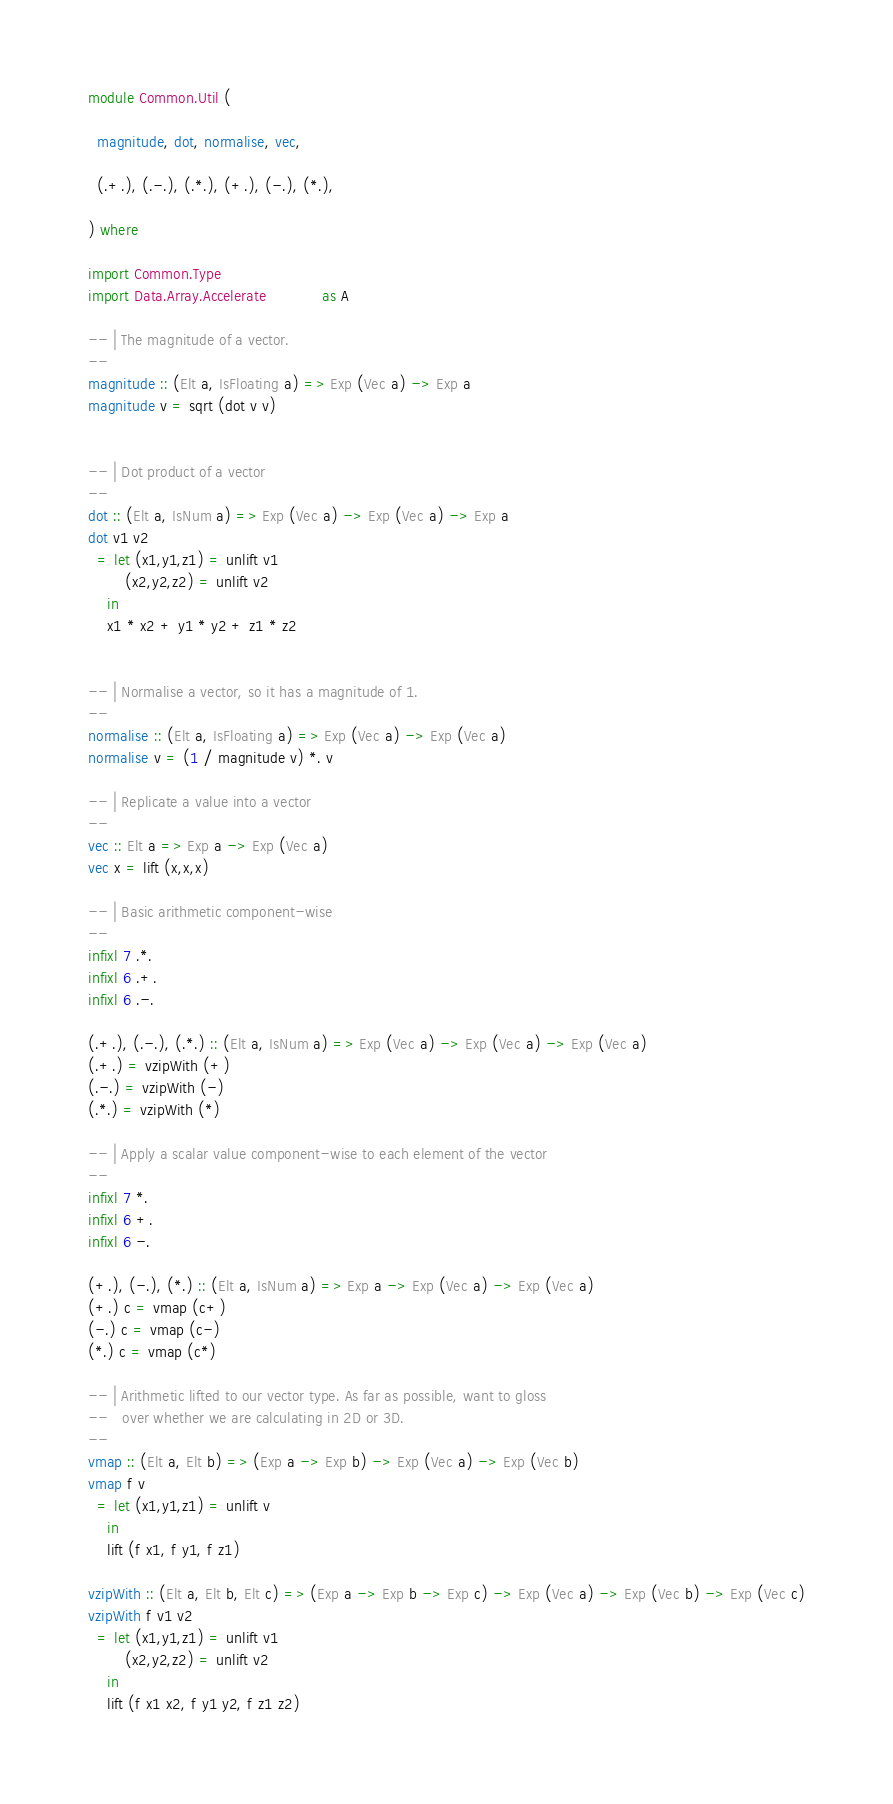<code> <loc_0><loc_0><loc_500><loc_500><_Haskell_>
module Common.Util (

  magnitude, dot, normalise, vec,

  (.+.), (.-.), (.*.), (+.), (-.), (*.),

) where

import Common.Type
import Data.Array.Accelerate            as A

-- | The magnitude of a vector.
--
magnitude :: (Elt a, IsFloating a) => Exp (Vec a) -> Exp a
magnitude v = sqrt (dot v v)


-- | Dot product of a vector
--
dot :: (Elt a, IsNum a) => Exp (Vec a) -> Exp (Vec a) -> Exp a
dot v1 v2
  = let (x1,y1,z1) = unlift v1
        (x2,y2,z2) = unlift v2
    in
    x1 * x2 + y1 * y2 + z1 * z2


-- | Normalise a vector, so it has a magnitude of 1.
--
normalise :: (Elt a, IsFloating a) => Exp (Vec a) -> Exp (Vec a)
normalise v = (1 / magnitude v) *. v

-- | Replicate a value into a vector
--
vec :: Elt a => Exp a -> Exp (Vec a)
vec x = lift (x,x,x)

-- | Basic arithmetic component-wise
--
infixl 7 .*.
infixl 6 .+.
infixl 6 .-.

(.+.), (.-.), (.*.) :: (Elt a, IsNum a) => Exp (Vec a) -> Exp (Vec a) -> Exp (Vec a)
(.+.) = vzipWith (+)
(.-.) = vzipWith (-)
(.*.) = vzipWith (*)

-- | Apply a scalar value component-wise to each element of the vector
--
infixl 7 *.
infixl 6 +.
infixl 6 -.

(+.), (-.), (*.) :: (Elt a, IsNum a) => Exp a -> Exp (Vec a) -> Exp (Vec a)
(+.) c = vmap (c+)
(-.) c = vmap (c-)
(*.) c = vmap (c*)

-- | Arithmetic lifted to our vector type. As far as possible, want to gloss
--   over whether we are calculating in 2D or 3D.
--
vmap :: (Elt a, Elt b) => (Exp a -> Exp b) -> Exp (Vec a) -> Exp (Vec b)
vmap f v
  = let (x1,y1,z1) = unlift v
    in
    lift (f x1, f y1, f z1)

vzipWith :: (Elt a, Elt b, Elt c) => (Exp a -> Exp b -> Exp c) -> Exp (Vec a) -> Exp (Vec b) -> Exp (Vec c)
vzipWith f v1 v2
  = let (x1,y1,z1) = unlift v1
        (x2,y2,z2) = unlift v2
    in
    lift (f x1 x2, f y1 y2, f z1 z2)

</code> 